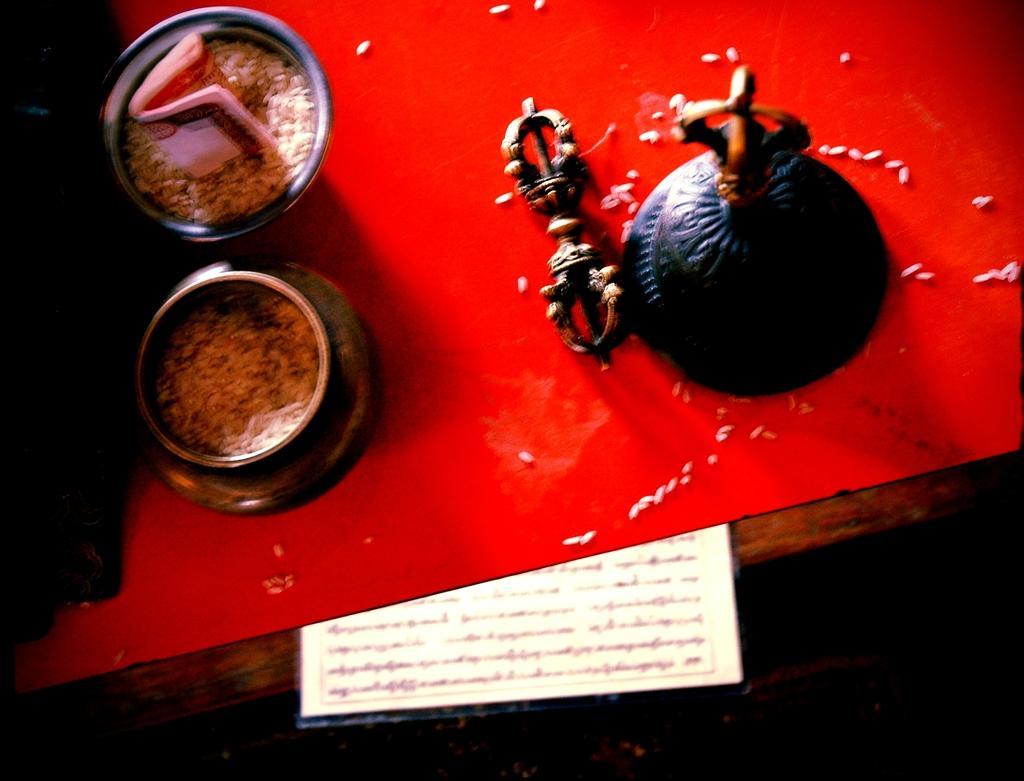Can you describe this image briefly? In this image we can see grains in the vessels, a paper with some text on it and a decor. 